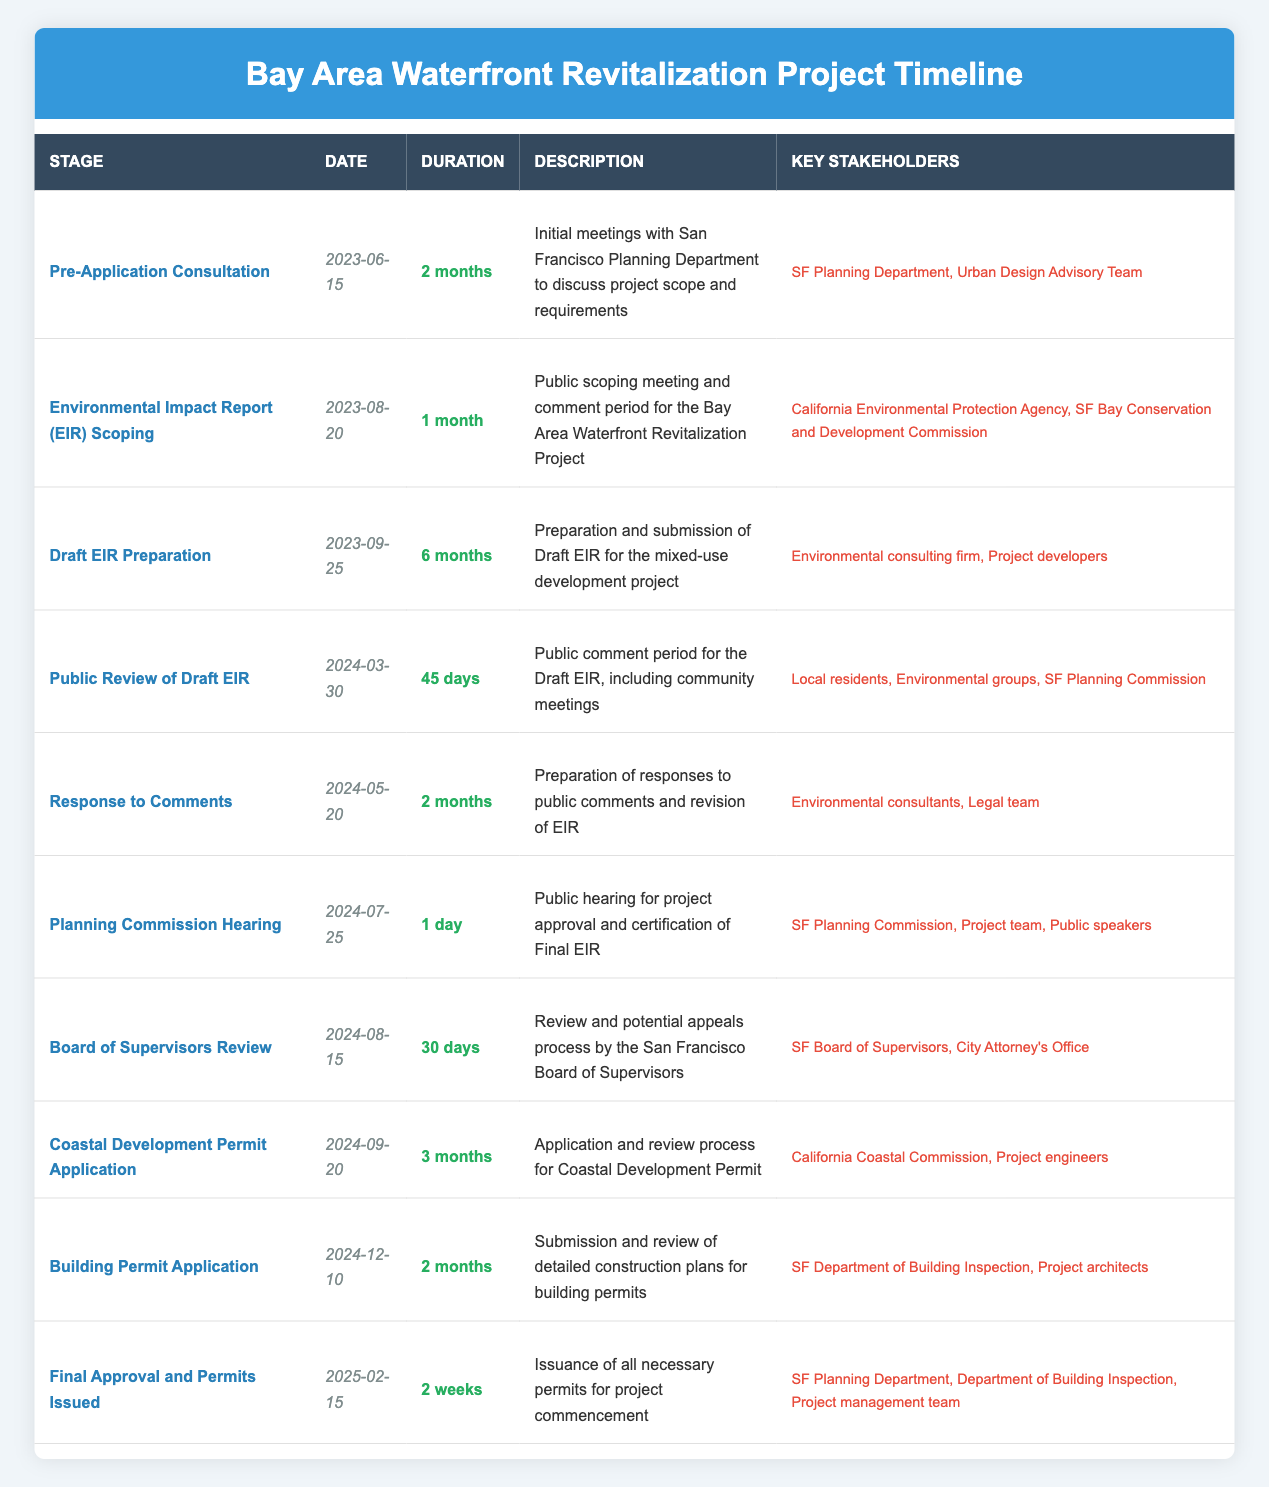What stage starts on August 20, 2023? Looking at the table, the stage listed for the date August 20, 2023, is "Environmental Impact Report (EIR) Scoping."
Answer: Environmental Impact Report (EIR) Scoping How long is the Public Review of Draft EIR stage? The duration for the "Public Review of Draft EIR" is specified as 45 days in the table.
Answer: 45 days Which key stakeholders are involved in the Planning Commission Hearing? The stakeholders mentioned for the "Planning Commission Hearing" stage include the SF Planning Commission, Project team, and Public speakers.
Answer: SF Planning Commission, Project team, Public speakers Is there a stage that lasts for 1 month? By scanning the durations in the table, the "Environmental Impact Report (EIR) Scoping" stage is the only one that lasts for 1 month.
Answer: Yes What is the total duration from the Draft EIR Preparation to the Final Approval and Permits Issued? The "Draft EIR Preparation" lasts for 6 months, "Response to Comments" lasts for 2 months, and "Planning Commission Hearing" lasts for 1 day (approximately 0 months). The "Board of Supervisors Review" lasts for 30 days (approximately 1 month), "Coastal Development Permit Application" for 3 months, "Building Permit Application" for 2 months, and "Final Approval and Permits Issued" lasts for 2 weeks (approximately 0.5 months). Adding these up gives: 6 + 2 + 0 + 1 + 3 + 2 + 0.5 = 14.5 months in total.
Answer: 14.5 months Who are the key stakeholders for the Coastal Development Permit Application? The stakeholders involved in the "Coastal Development Permit Application" stage are the California Coastal Commission and Project engineers.
Answer: California Coastal Commission, Project engineers 